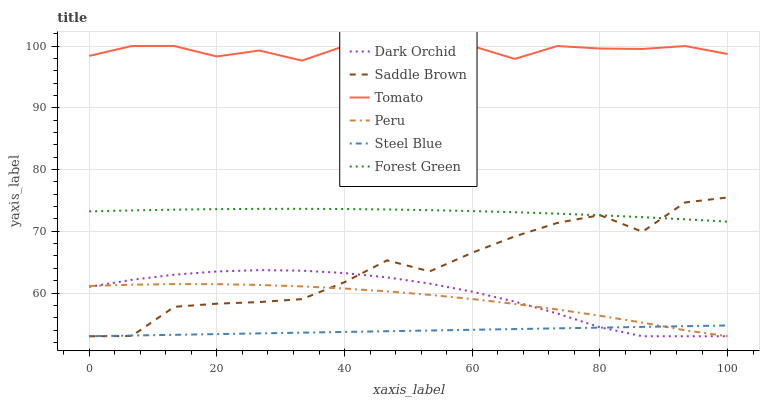Does Steel Blue have the minimum area under the curve?
Answer yes or no. Yes. Does Tomato have the maximum area under the curve?
Answer yes or no. Yes. Does Dark Orchid have the minimum area under the curve?
Answer yes or no. No. Does Dark Orchid have the maximum area under the curve?
Answer yes or no. No. Is Steel Blue the smoothest?
Answer yes or no. Yes. Is Saddle Brown the roughest?
Answer yes or no. Yes. Is Dark Orchid the smoothest?
Answer yes or no. No. Is Dark Orchid the roughest?
Answer yes or no. No. Does Forest Green have the lowest value?
Answer yes or no. No. Does Dark Orchid have the highest value?
Answer yes or no. No. Is Forest Green less than Tomato?
Answer yes or no. Yes. Is Forest Green greater than Steel Blue?
Answer yes or no. Yes. Does Forest Green intersect Tomato?
Answer yes or no. No. 